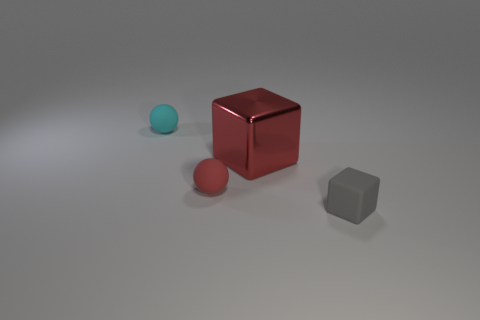Add 2 cyan cylinders. How many objects exist? 6 Add 3 small red matte things. How many small red matte things exist? 4 Subtract 0 cyan blocks. How many objects are left? 4 Subtract all tiny cyan matte spheres. Subtract all cyan spheres. How many objects are left? 2 Add 2 cyan objects. How many cyan objects are left? 3 